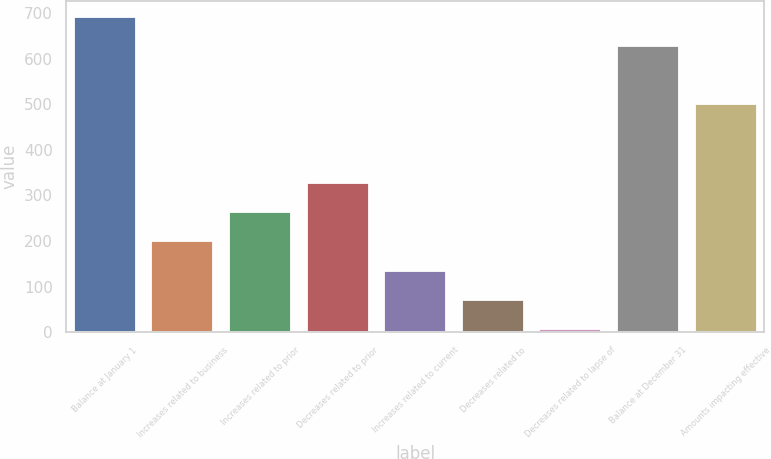<chart> <loc_0><loc_0><loc_500><loc_500><bar_chart><fcel>Balance at January 1<fcel>Increases related to business<fcel>Increases related to prior<fcel>Decreases related to prior<fcel>Increases related to current<fcel>Decreases related to<fcel>Decreases related to lapse of<fcel>Balance at December 31<fcel>Amounts impacting effective<nl><fcel>691.09<fcel>199.27<fcel>263.56<fcel>327.85<fcel>134.98<fcel>70.69<fcel>6.4<fcel>626.8<fcel>499.6<nl></chart> 